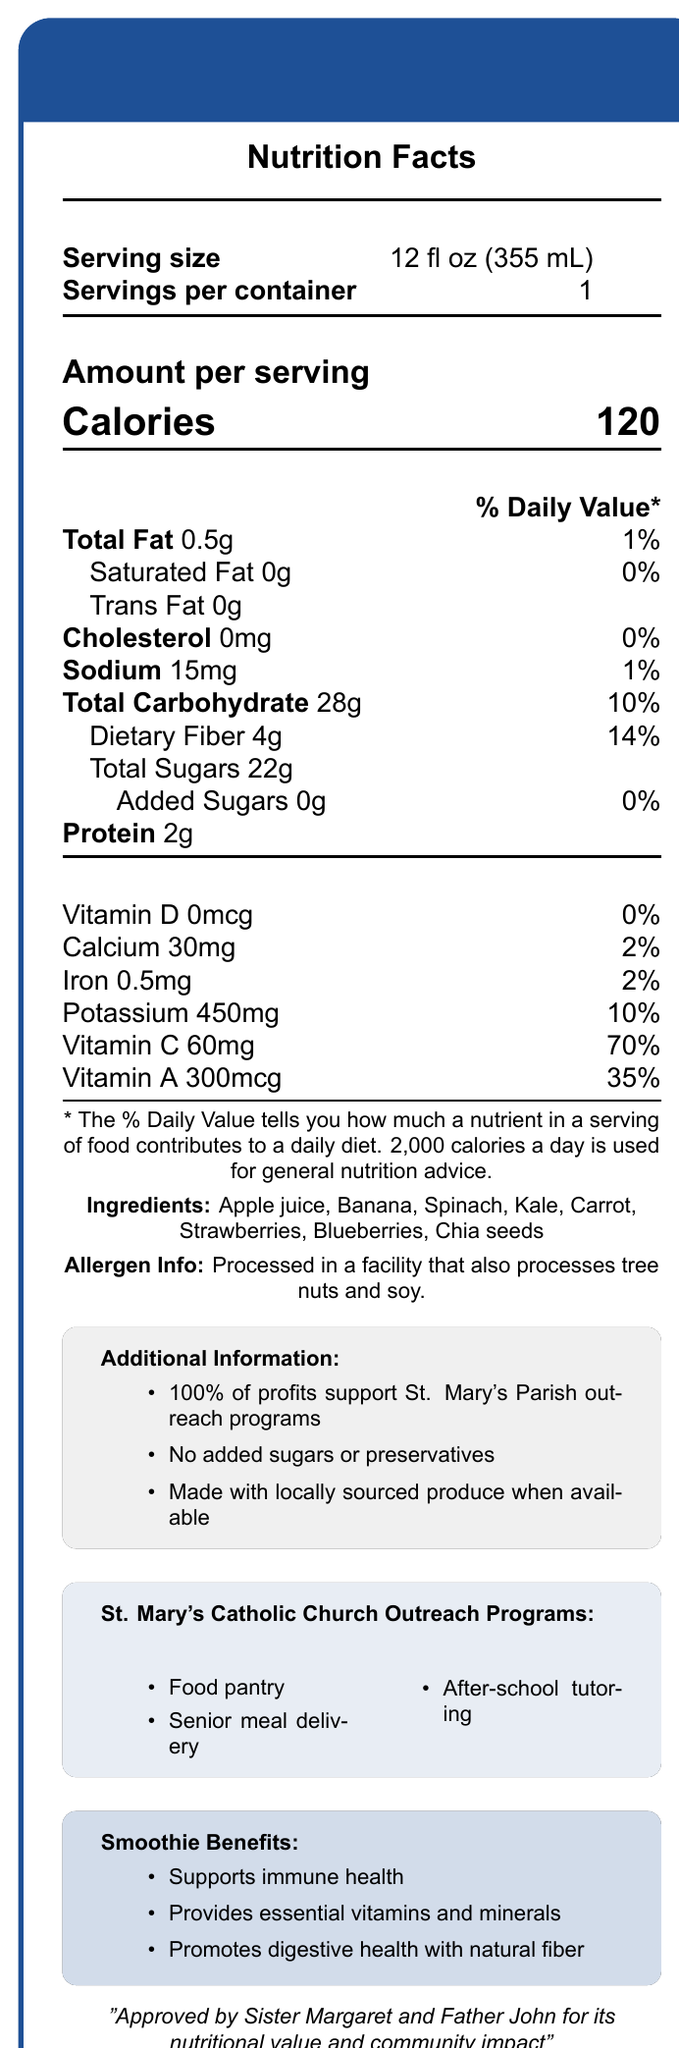what is the serving size of the Parish Outreach Fruit & Veggie Blend? The serving size is listed at the top of the Nutrition Facts section as 12 fl oz (355 mL).
Answer: 12 fl oz (355 mL) how many calories are in one serving? The calories per serving is listed as 120 in the amount per serving section.
Answer: 120 calories what percentage of the daily value is provided by the dietary fiber in one serving? The document lists the daily value for dietary fiber as 14%.
Answer: 14% how much sodium does one serving contain? The sodium content is listed as 15 mg in the nutrition information.
Answer: 15 mg what ingredients are used in the smoothie? The ingredients are listed towards the bottom of the Nutrition Facts section.
Answer: Apple juice, Banana, Spinach, Kale, Carrot, Strawberries, Blueberries, Chia seeds how much protein does one serving of the smoothie provide? The protein content is stated as 2g in the nutrition information section.
Answer: 2g what is the main vitamin provided by the smoothie and its daily value percentage? Vitamin C is listed as providing 70% of the daily value, which is the highest percentage among the vitamins and minerals listed.
Answer: Vitamin C, 70% what are some of the benefits of the smoothie listed in the document? The benefits are listed under the "Smoothie Benefits" section.
Answer: Supports immune health, Provides essential vitamins and minerals, Promotes digestive health with natural fiber who approved the smoothie for its nutritional value and community impact? The document states that Sister Margaret and Father John approved the smoothie for its nutritional value and community impact.
Answer: Sister Margaret and Father John which outreach programs benefit from the profits of the smoothie sales? A. Youth ministry, B. Food pantry, C. Homeless shelter, D. Senior meal delivery The document specifies that profits support St. Mary's Parish outreach programs including the Food pantry, Senior meal delivery, and After-school tutoring.
Answer: B. Food pantry, D. Senior meal delivery what is the highest percentage daily value nutrient in the smoothie? A. Calcium, B. Iron, C. Vitamin A, D. Vitamin C The daily value for Vitamin C is listed as 70%, the highest among all nutrients.
Answer: D. Vitamin C is the smoothie made with locally sourced produce when available? The document indicates that the smoothie is made with locally sourced produce when available.
Answer: Yes what is the main purpose of the document overall? The document serves to inform about the nutritional content of the smoothie, its health benefits, ingredients, and the outreach programs it supports.
Answer: To provide nutritional information and promote the Parish Outreach Fruit & Veggie Blend while highlighting its benefits and community impact. how much Vitamin D does one serving contain? The document lists the amount of Vitamin D but does not provide detailed benefits or context beyond the daily value percentage of 0%.
Answer: Not enough information in what type of facility is the smoothie processed? The allergen information indicates the processing facility also handles tree nuts and soy.
Answer: Facility that also processes tree nuts and soy 